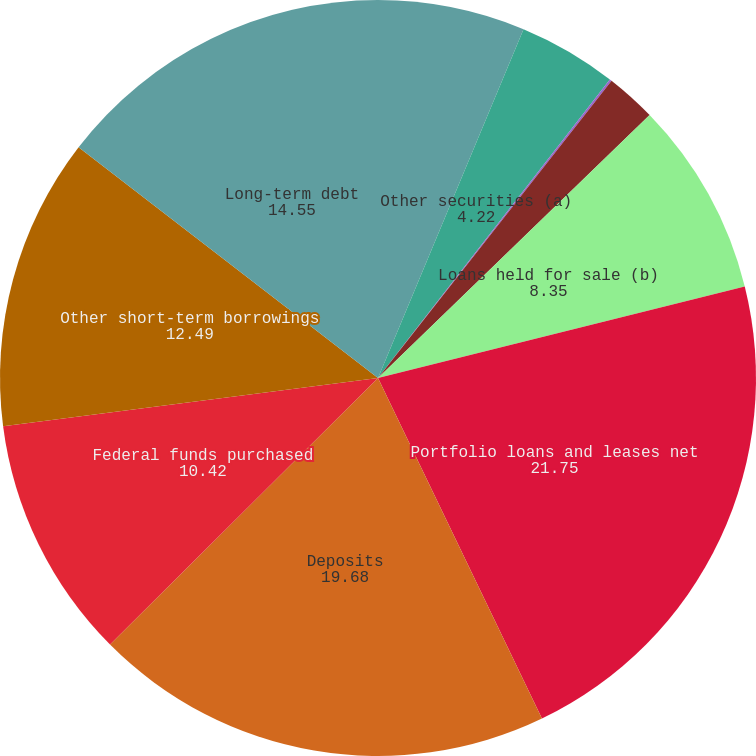Convert chart. <chart><loc_0><loc_0><loc_500><loc_500><pie_chart><fcel>Cash and due from banks<fcel>Other securities (a)<fcel>Held-to-maturity securities<fcel>Other short-term investments<fcel>Loans held for sale (b)<fcel>Portfolio loans and leases net<fcel>Deposits<fcel>Federal funds purchased<fcel>Other short-term borrowings<fcel>Long-term debt<nl><fcel>6.29%<fcel>4.22%<fcel>0.09%<fcel>2.16%<fcel>8.35%<fcel>21.75%<fcel>19.68%<fcel>10.42%<fcel>12.49%<fcel>14.55%<nl></chart> 